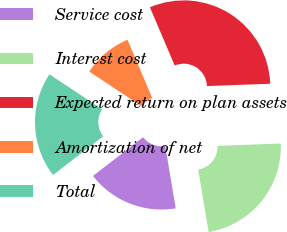Convert chart to OTSL. <chart><loc_0><loc_0><loc_500><loc_500><pie_chart><fcel>Service cost<fcel>Interest cost<fcel>Expected return on plan assets<fcel>Amortization of net<fcel>Total<nl><fcel>17.16%<fcel>22.94%<fcel>30.82%<fcel>9.28%<fcel>19.79%<nl></chart> 